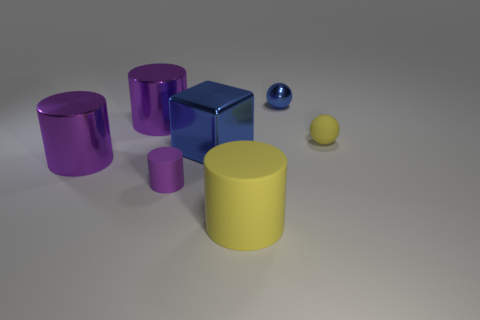What is the large yellow cylinder made of?
Your response must be concise. Rubber. Do the shiny ball and the block that is behind the yellow cylinder have the same color?
Make the answer very short. Yes. How many blocks are red objects or big matte things?
Your response must be concise. 0. There is a tiny object that is to the left of the tiny blue shiny sphere; what color is it?
Give a very brief answer. Purple. There is a tiny object that is the same color as the metallic cube; what is its shape?
Provide a short and direct response. Sphere. How many things have the same size as the yellow ball?
Make the answer very short. 2. There is a tiny metallic thing that is on the right side of the large blue cube; is its shape the same as the blue shiny thing that is in front of the blue metallic sphere?
Offer a terse response. No. The large purple cylinder that is behind the big metallic thing right of the small thing left of the big blue cube is made of what material?
Your answer should be very brief. Metal. There is a metal object that is the same size as the yellow sphere; what shape is it?
Offer a very short reply. Sphere. Is there a large metallic thing that has the same color as the tiny matte cylinder?
Provide a succinct answer. Yes. 